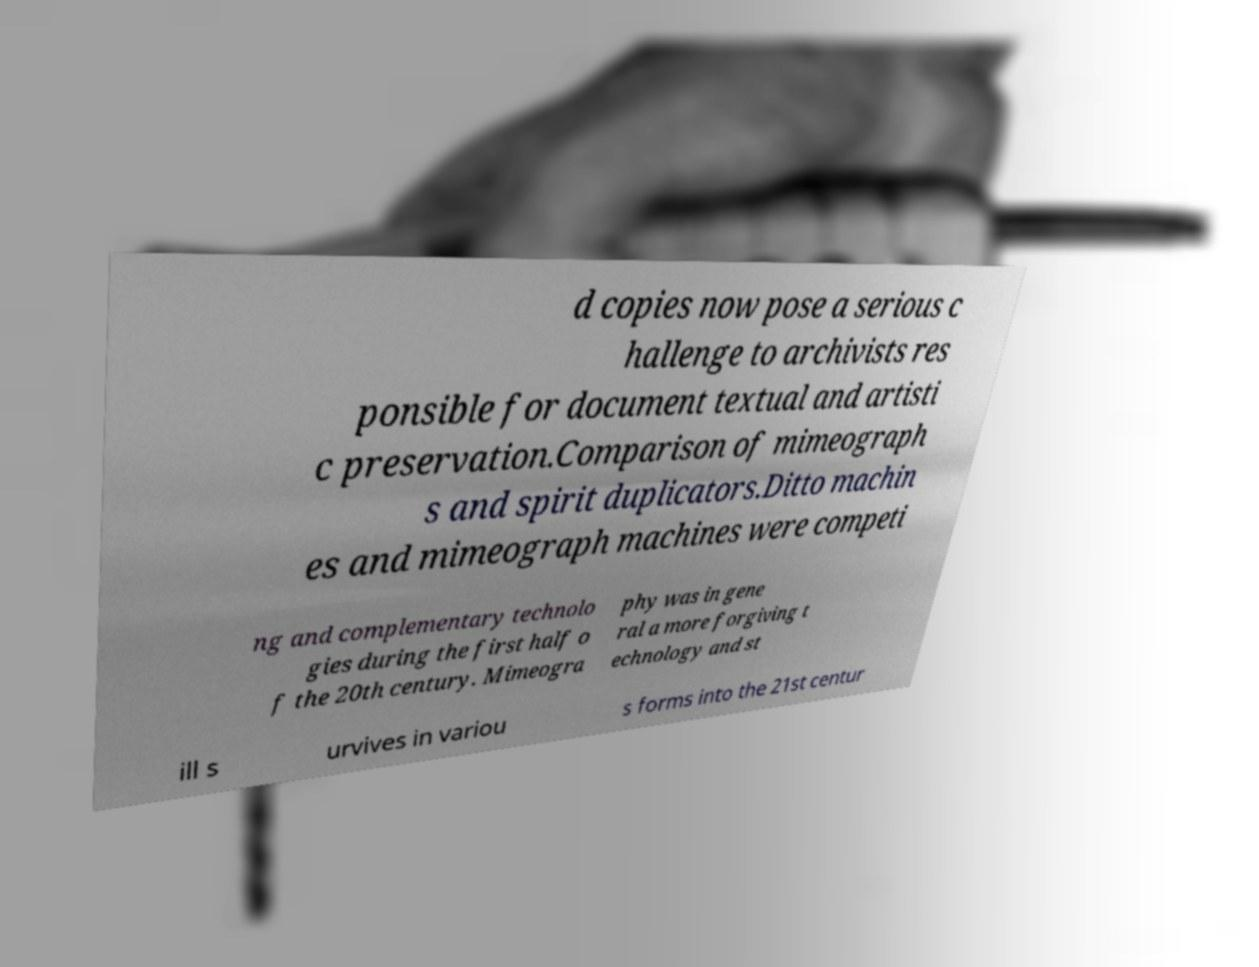What messages or text are displayed in this image? I need them in a readable, typed format. d copies now pose a serious c hallenge to archivists res ponsible for document textual and artisti c preservation.Comparison of mimeograph s and spirit duplicators.Ditto machin es and mimeograph machines were competi ng and complementary technolo gies during the first half o f the 20th century. Mimeogra phy was in gene ral a more forgiving t echnology and st ill s urvives in variou s forms into the 21st centur 